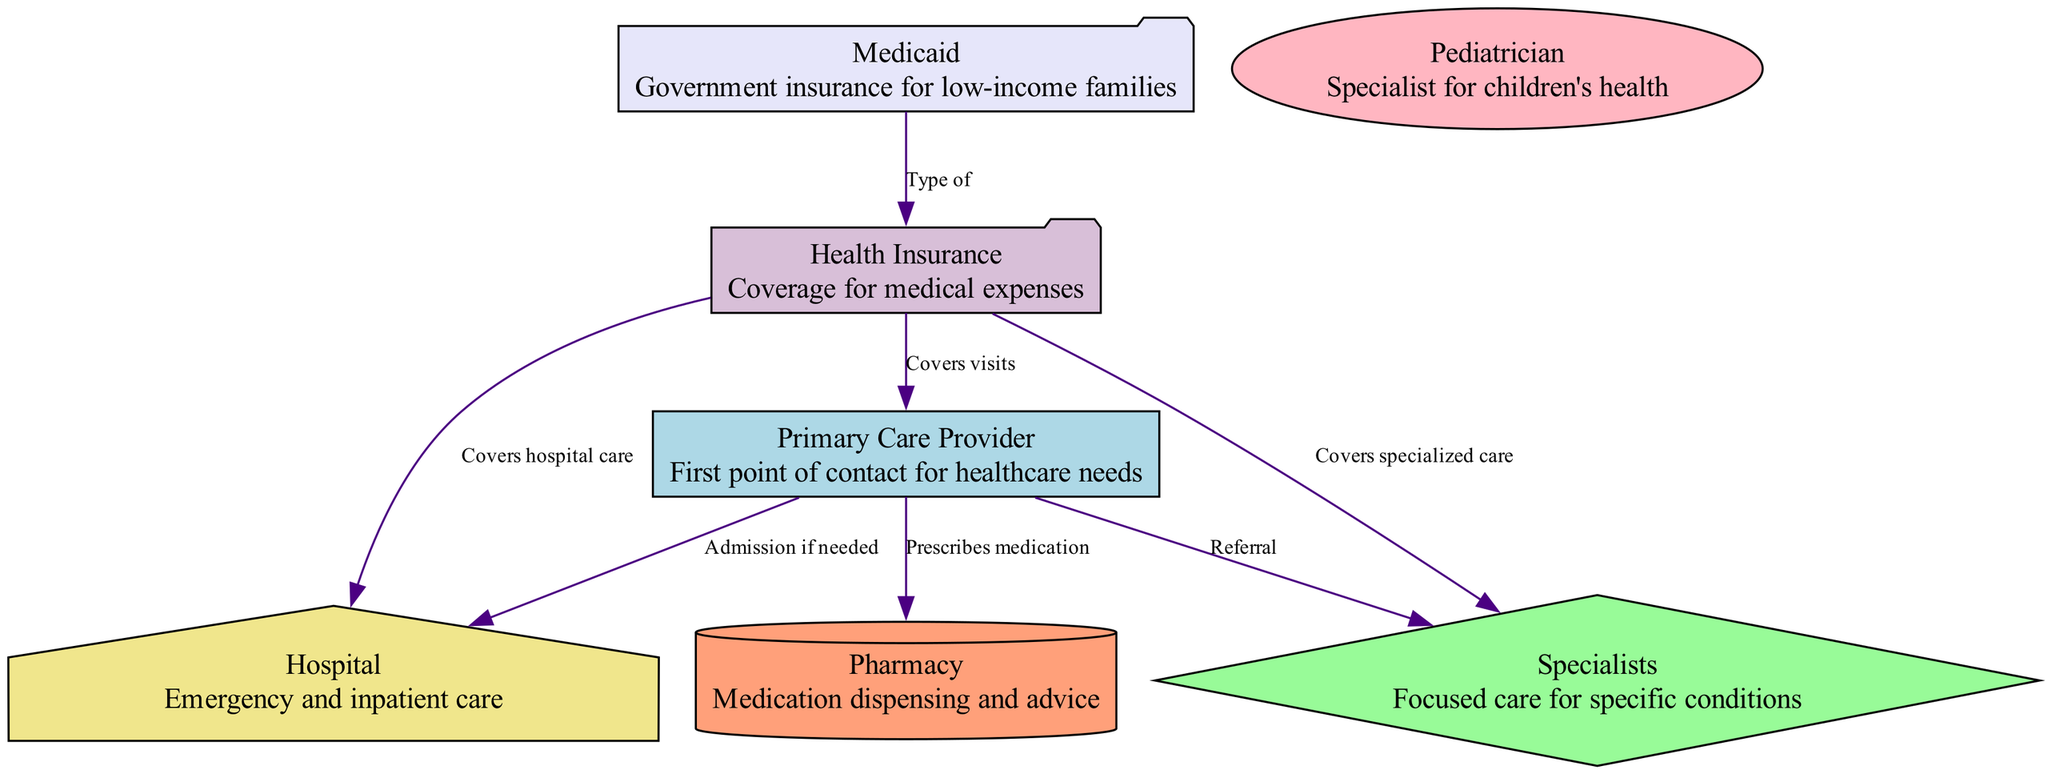What is the first point of contact for healthcare needs? The diagram indicates that the "Primary Care Provider" is labeled as the first point of contact for healthcare needs, which is explicitly described in its node.
Answer: Primary Care Provider How many types of insurance are represented in the diagram? The diagram contains two categories related to insurance: "Health Insurance" and "Medicaid." Therefore, there are two types represented.
Answer: 2 What does the primary care provider do when specialized care is needed? According to the diagram, the Primary Care Provider refers patients to "Specialists" when specialized care is required, which is shown by the labeled edge leading from Primary Care Provider to Specialist.
Answer: Referral What type of care does the hospital provide? The diagram describes the "Hospital" as providing "Emergency and inpatient care," which clearly states the type of care associated with this node.
Answer: Emergency and inpatient care Which nodes have a direct connection to the pharmacy? The diagram shows a direct connection from the "Primary Care Provider" to the "Pharmacy" indicating that medication is prescribed by the Primary Care Provider and dispensed at the Pharmacy. This defines the direct interaction between these nodes.
Answer: Primary Care Provider What insurance covers hospital care? The diagram shows that "Health Insurance" covers "hospital care," which can be confirmed by the connecting edge labeled appropriately in the diagram.
Answer: Health Insurance How many relationships (edges) are there in total in this diagram? As counted from the diagram, there are a total of six relationships (edges) established between the nodes, detailing how they connect and interact with one another.
Answer: 6 What is Medicaid a type of? The diagram indicates that "Medicaid" is a type of "Health Insurance," as demonstrated by the directed edge linking Medicaid to the insurance node and labeled accordingly.
Answer: Type of What does the primary care provider usually prescribe? The diagram directly states that the "Primary Care Provider" prescribes medication, as highlighted in the connection to the "Pharmacy." This gives the stated function associated with this node's role.
Answer: Medication 